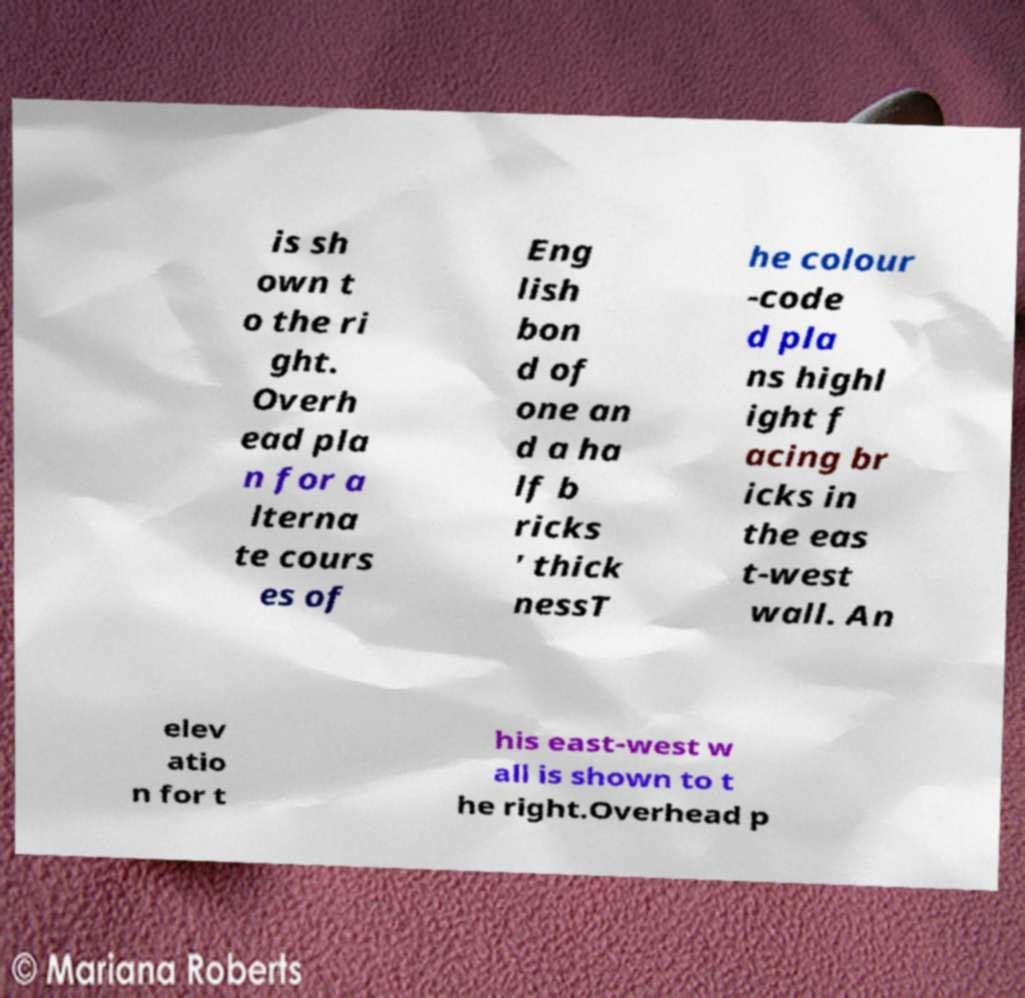Could you assist in decoding the text presented in this image and type it out clearly? is sh own t o the ri ght. Overh ead pla n for a lterna te cours es of Eng lish bon d of one an d a ha lf b ricks ' thick nessT he colour -code d pla ns highl ight f acing br icks in the eas t-west wall. An elev atio n for t his east-west w all is shown to t he right.Overhead p 